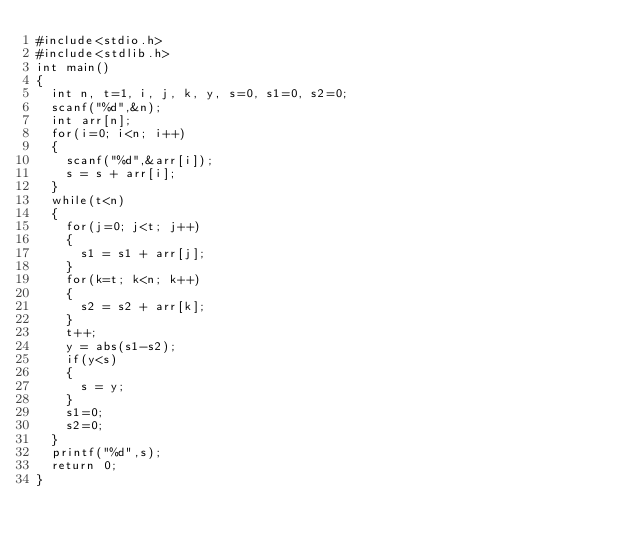Convert code to text. <code><loc_0><loc_0><loc_500><loc_500><_C_>#include<stdio.h>
#include<stdlib.h>
int main()
{
  int n, t=1, i, j, k, y, s=0, s1=0, s2=0;
  scanf("%d",&n);
  int arr[n];
  for(i=0; i<n; i++)
  {
    scanf("%d",&arr[i]);
    s = s + arr[i];
  }
  while(t<n)
  {
    for(j=0; j<t; j++)
    {
      s1 = s1 + arr[j];
    }
    for(k=t; k<n; k++)
    {
      s2 = s2 + arr[k];
    }
    t++;
    y = abs(s1-s2);
    if(y<s)
    {
      s = y;
    }
    s1=0;
    s2=0;
  }
  printf("%d",s);
  return 0;
}</code> 